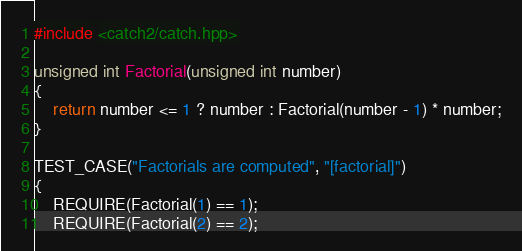Convert code to text. <code><loc_0><loc_0><loc_500><loc_500><_C++_>#include <catch2/catch.hpp>

unsigned int Factorial(unsigned int number)
{
    return number <= 1 ? number : Factorial(number - 1) * number;
}

TEST_CASE("Factorials are computed", "[factorial]")
{
    REQUIRE(Factorial(1) == 1);
    REQUIRE(Factorial(2) == 2);</code> 